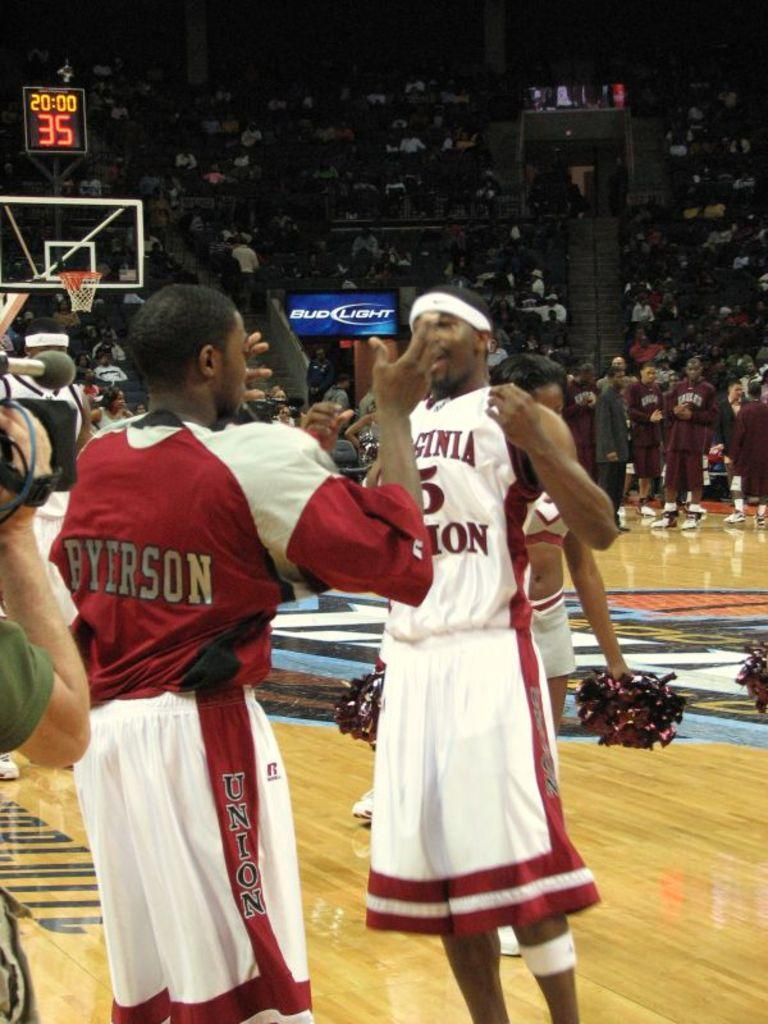<image>
Write a terse but informative summary of the picture. A player with shorts that say Union on them does a handshake with another player. 